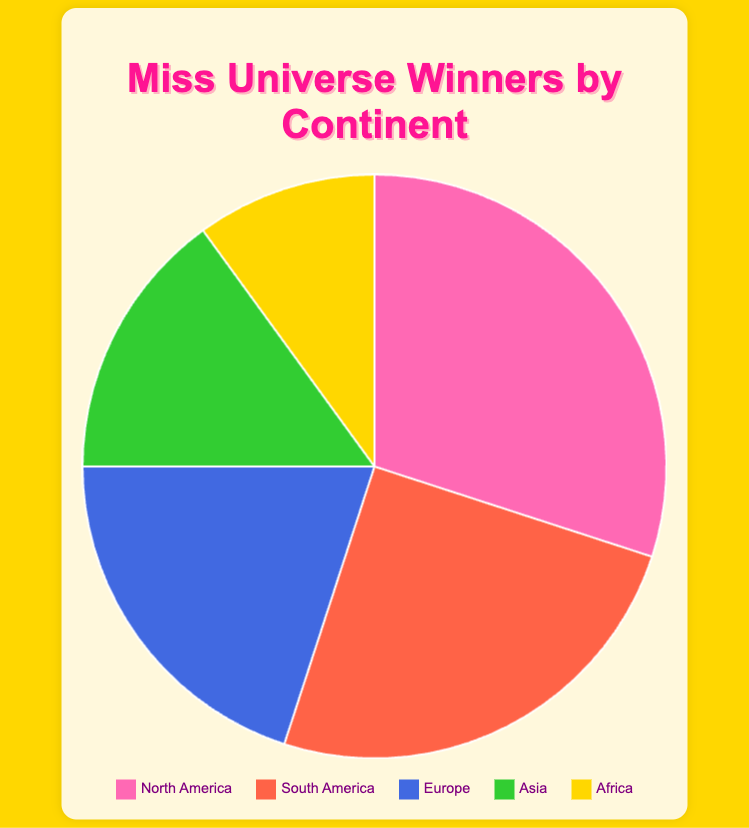What percentage of Miss Universe winners come from North America? Based on the pie chart, North America contributes 30% of the total Miss Universe winners.
Answer: 30% Which continent has the second highest percentage of Miss Universe winners? The pie chart shows that South America has the second highest percentage of Miss Universe winners, contributing 25%.
Answer: South America How do the combined percentages of Asia and Africa compare to North America's percentage? Asia has 15% and Africa has 10%. Combined, Asia and Africa account for 25% of the winners (15% + 10%). North America has 30%, so North America's percentage is higher than the combined percentage of Asia and Africa.
Answer: North America has a higher percentage What is the total percentage of Miss Universe winners from continents other than Europe? To find this, subtract Europe's percentage from 100%: 100% - 20% = 80%. Thus, a total of 80% of Miss Universe winners come from continents other than Europe.
Answer: 80% Which continent has the least representation of Miss Universe winners? The pie chart indicates that Africa has the smallest percentage of Miss Universe winners, contributing only 10%.
Answer: Africa How much greater is the percentage of Miss Universe winners from South America compared to those from Asia? South America has 25% and Asia has 15%. The difference is 25% - 15% = 10%.
Answer: 10% If the percentage of Miss Universe winners from Europe increased by 5%, how would it compare to the total percentage of winners from Asia? If Europe's percentage increased by 5%, it would be 20% + 5% = 25%. This would equal the current percentage of winners from South America and be greater than Asia's 15%.
Answer: Europe would have a higher percentage Which continent is represented by the color blue in the pie chart? The legend shows that Europe is represented by the color blue in the pie chart.
Answer: Europe What is the combined percentage of Miss Universe winners from North America and South America? North America has 30% and South America has 25%. Combined, they make up 30% + 25% = 55%.
Answer: 55% If Asia and Africa's percentages were combined, would it be more or less than Europe's percentage? Asia has 15% and Africa has 10%. Combined, they amount to 25% (15% + 10%). Europe's percentage is 20%. Therefore, Asia and Africa combined have a higher percentage than Europe.
Answer: More 